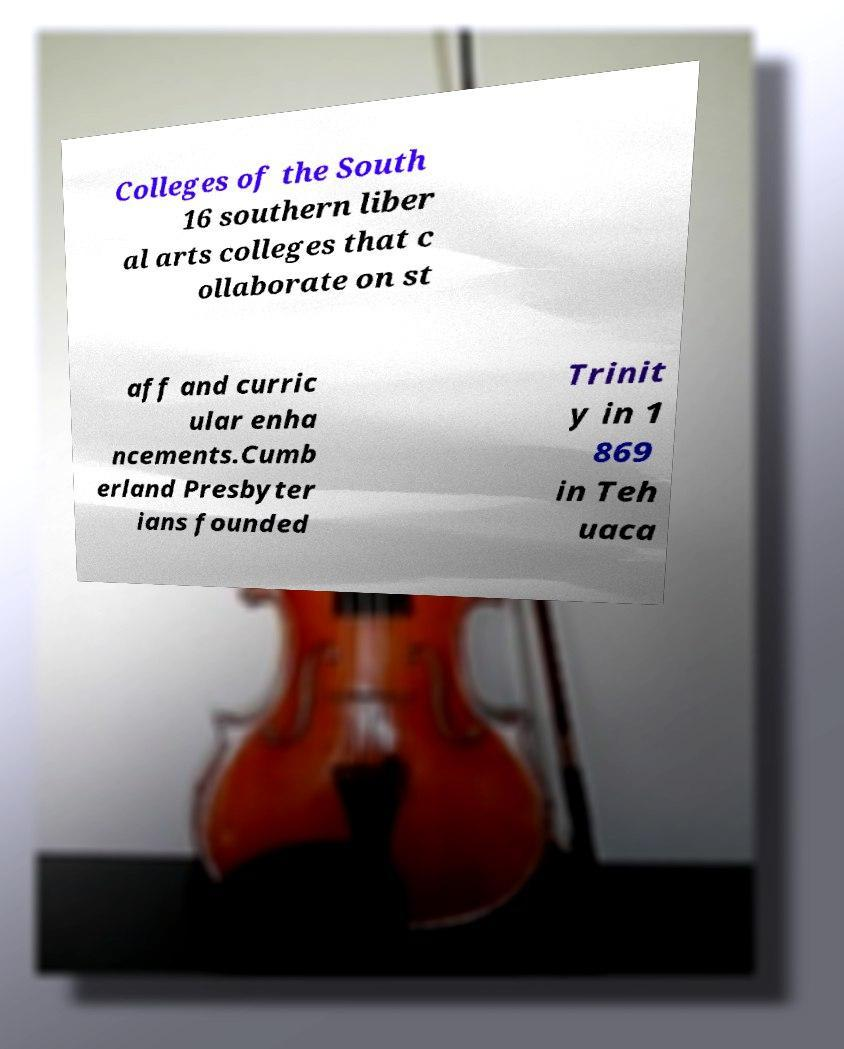Can you accurately transcribe the text from the provided image for me? Colleges of the South 16 southern liber al arts colleges that c ollaborate on st aff and curric ular enha ncements.Cumb erland Presbyter ians founded Trinit y in 1 869 in Teh uaca 